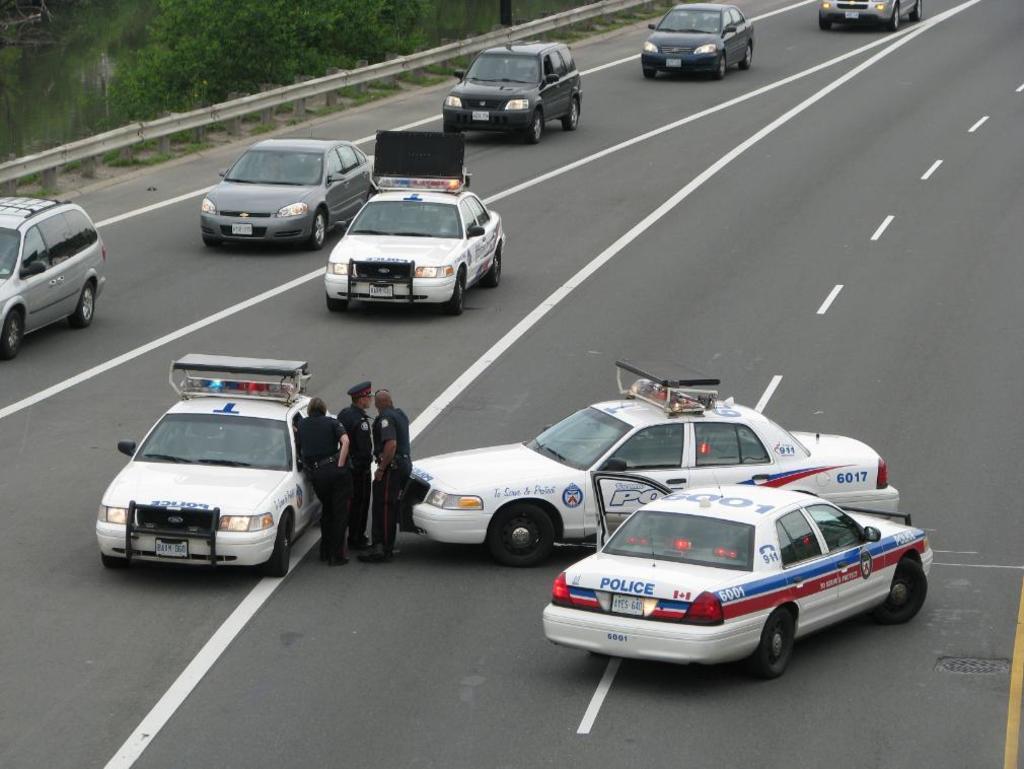Can you describe this image briefly? In this image, we can see few vehicles on the road. Here we can see white lines. In the middle of the image, we can see few people are standing on the road. Left side top corner, we can see railing, plants and grass. Here we can see a pole. 